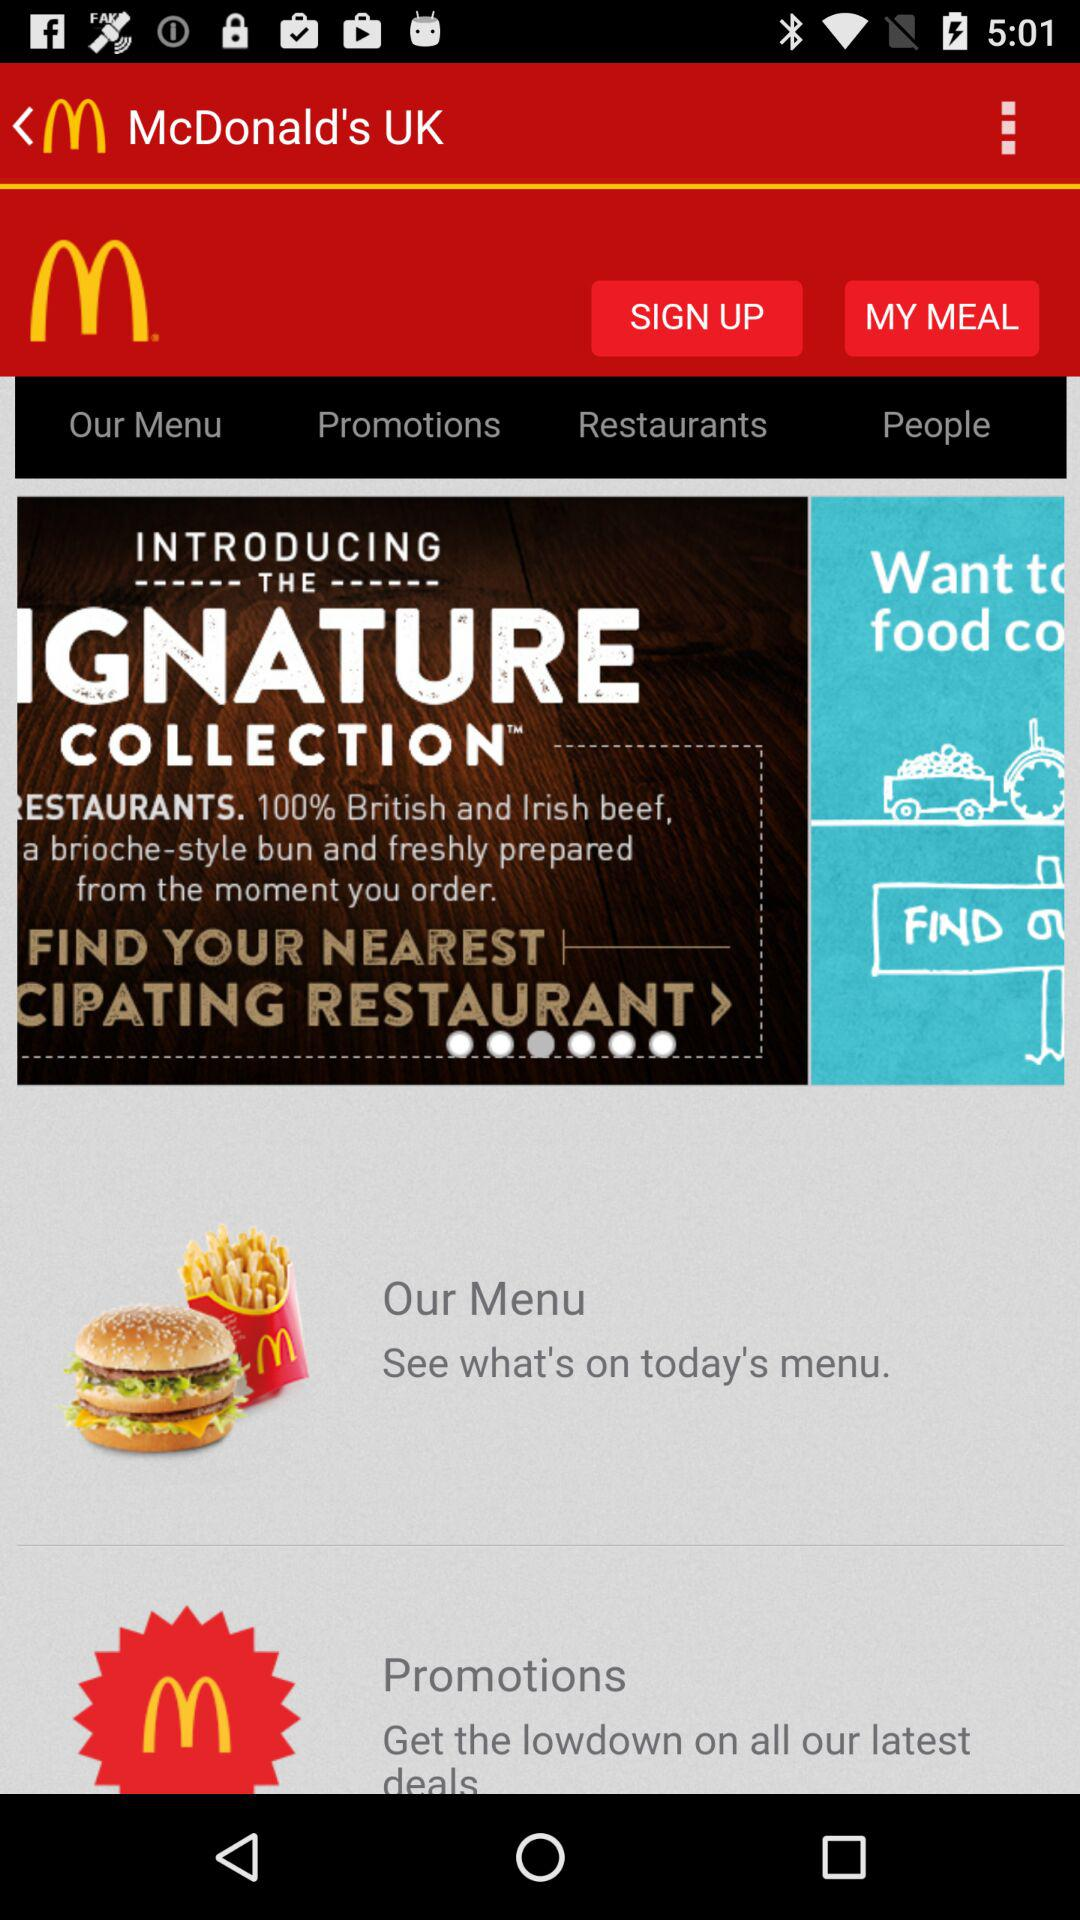What variety of beef is served? The variety of beef served is 100% British and Irish. 